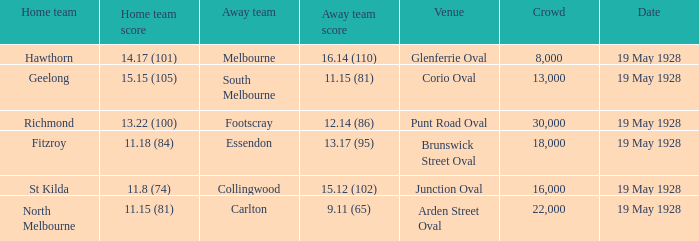Which location showcased an audience of more than 30,000 people? None. 